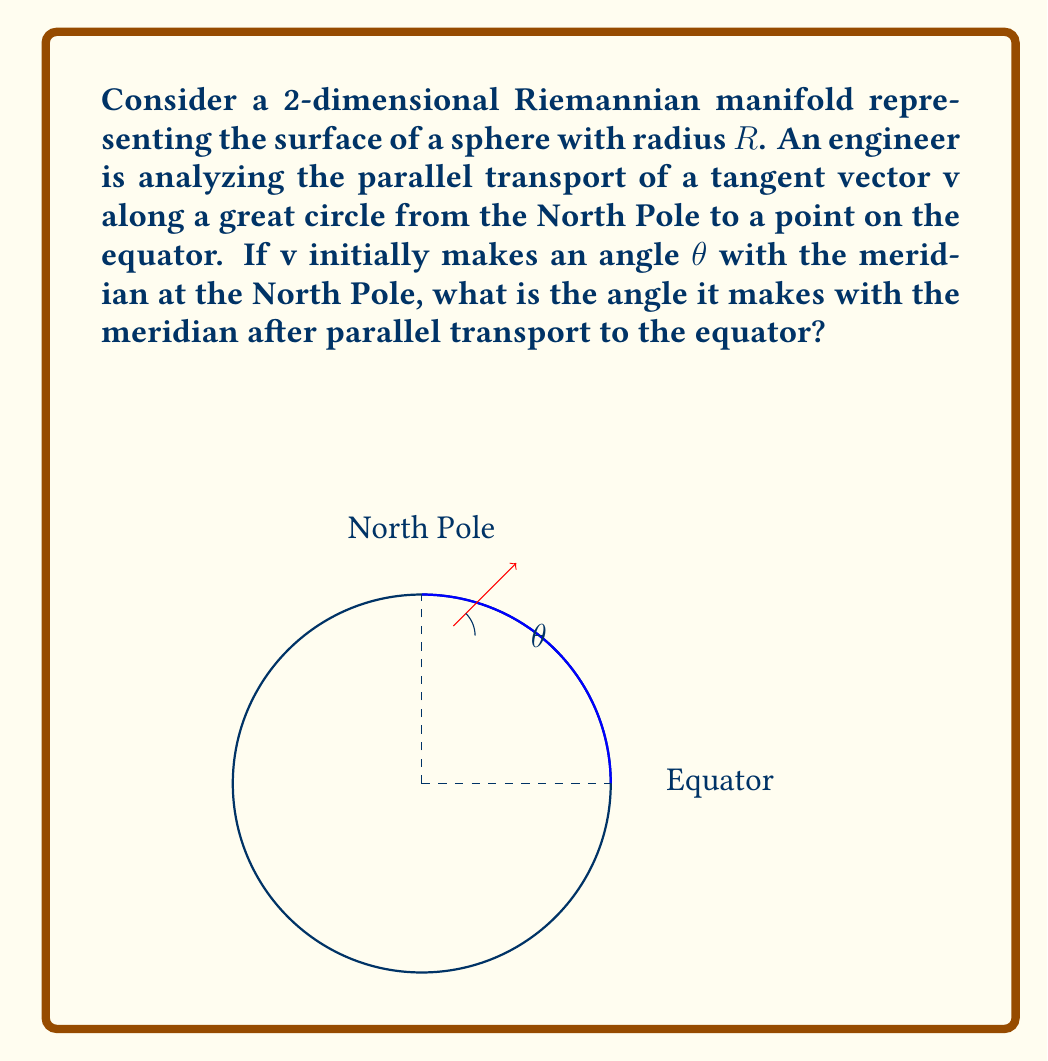Help me with this question. Let's approach this problem step-by-step:

1) In a sphere, parallel transport along a great circle rotates the vector by an angle equal to the angle traversed along the great circle.

2) The angle traversed from the North Pole to the equator is 90° or $\frac{\pi}{2}$ radians.

3) The parallel transport will rotate the vector $\mathbf{v}$ by 90° in the opposite direction of the curve's rotation.

4) Initially, $\mathbf{v}$ makes an angle $\theta$ with the meridian at the North Pole.

5) After parallel transport, the new angle $\theta'$ will be:

   $$\theta' = \theta + \frac{\pi}{2}$$

6) However, we need to consider that the meridian at the equator is perpendicular to the meridian at the North Pole.

7) Therefore, to find the angle with respect to the meridian at the equator, we need to subtract $\frac{\pi}{2}$ from our result:

   $$\theta_{final} = \theta' - \frac{\pi}{2} = (\theta + \frac{\pi}{2}) - \frac{\pi}{2} = \theta$$

8) This shows that the angle the vector makes with the meridian remains unchanged after parallel transport from the North Pole to the equator.

This result illustrates an important property of parallel transport on a sphere: a vector parallel transported along a great circle from the North Pole to the equator maintains its angle with respect to the meridian.
Answer: $\theta$ 